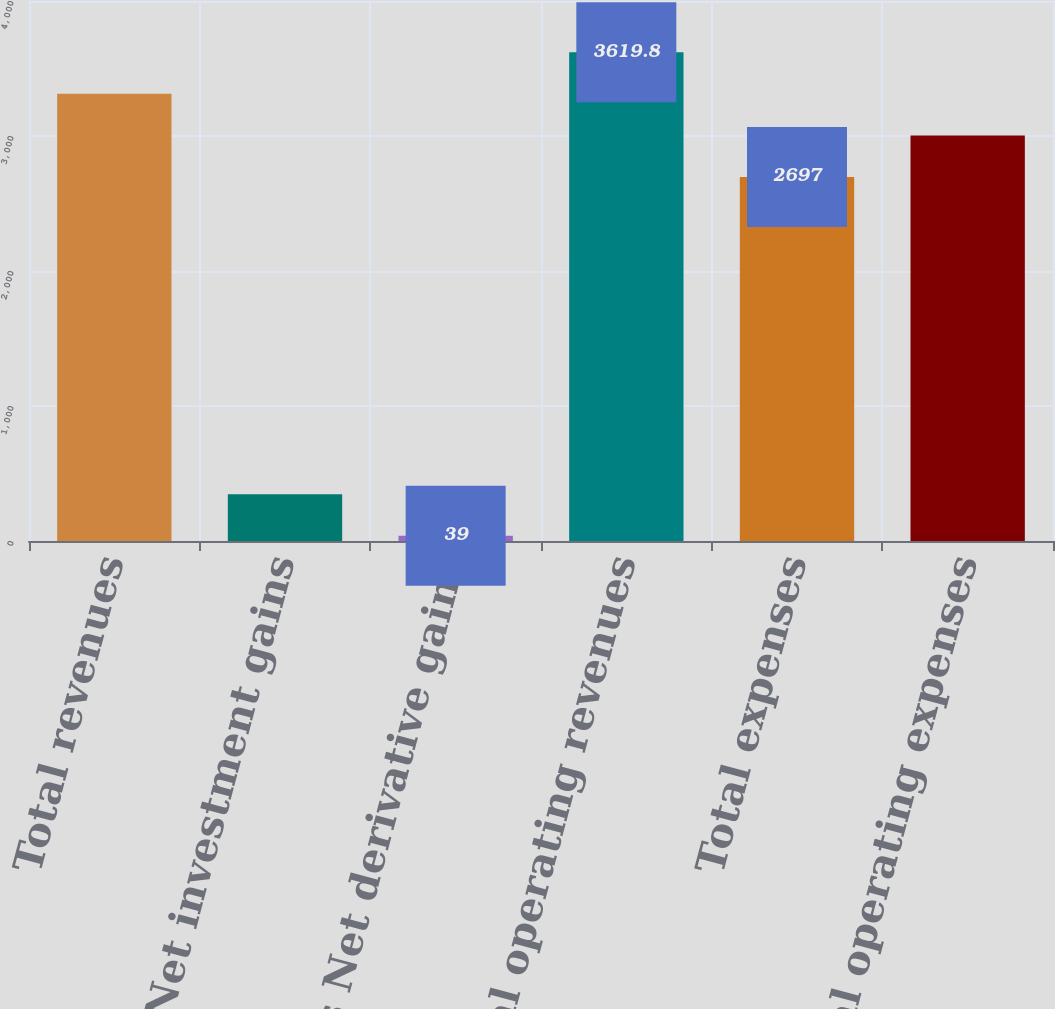<chart> <loc_0><loc_0><loc_500><loc_500><bar_chart><fcel>Total revenues<fcel>Less Net investment gains<fcel>Less Net derivative gains<fcel>Total operating revenues<fcel>Total expenses<fcel>Total operating expenses<nl><fcel>3312.2<fcel>346.6<fcel>39<fcel>3619.8<fcel>2697<fcel>3004.6<nl></chart> 